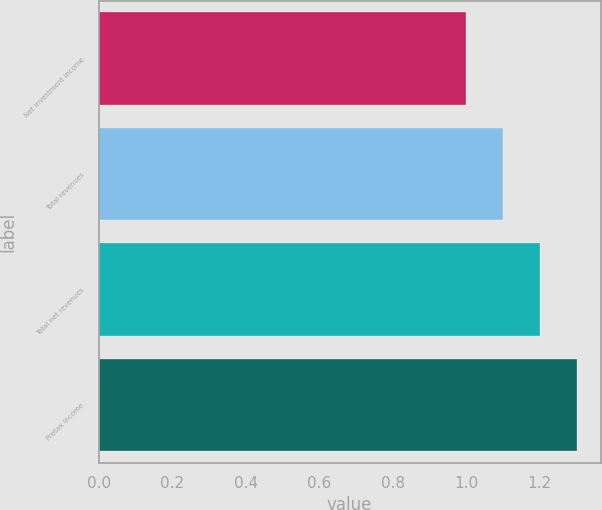Convert chart. <chart><loc_0><loc_0><loc_500><loc_500><bar_chart><fcel>Net investment income<fcel>Total revenues<fcel>Total net revenues<fcel>Pretax income<nl><fcel>1<fcel>1.1<fcel>1.2<fcel>1.3<nl></chart> 